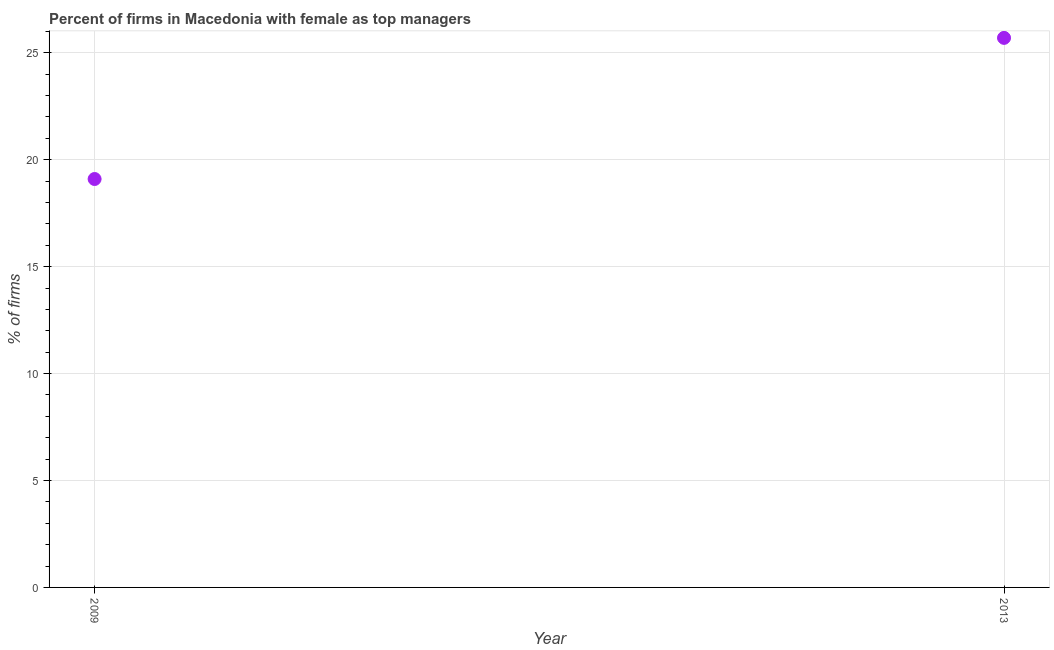What is the percentage of firms with female as top manager in 2009?
Your answer should be compact. 19.1. Across all years, what is the maximum percentage of firms with female as top manager?
Your answer should be compact. 25.7. Across all years, what is the minimum percentage of firms with female as top manager?
Ensure brevity in your answer.  19.1. In which year was the percentage of firms with female as top manager maximum?
Keep it short and to the point. 2013. In which year was the percentage of firms with female as top manager minimum?
Provide a succinct answer. 2009. What is the sum of the percentage of firms with female as top manager?
Keep it short and to the point. 44.8. What is the difference between the percentage of firms with female as top manager in 2009 and 2013?
Make the answer very short. -6.6. What is the average percentage of firms with female as top manager per year?
Make the answer very short. 22.4. What is the median percentage of firms with female as top manager?
Make the answer very short. 22.4. What is the ratio of the percentage of firms with female as top manager in 2009 to that in 2013?
Make the answer very short. 0.74. How many dotlines are there?
Provide a succinct answer. 1. How many years are there in the graph?
Provide a succinct answer. 2. Does the graph contain any zero values?
Your response must be concise. No. What is the title of the graph?
Give a very brief answer. Percent of firms in Macedonia with female as top managers. What is the label or title of the Y-axis?
Provide a short and direct response. % of firms. What is the % of firms in 2009?
Keep it short and to the point. 19.1. What is the % of firms in 2013?
Provide a succinct answer. 25.7. What is the ratio of the % of firms in 2009 to that in 2013?
Offer a very short reply. 0.74. 